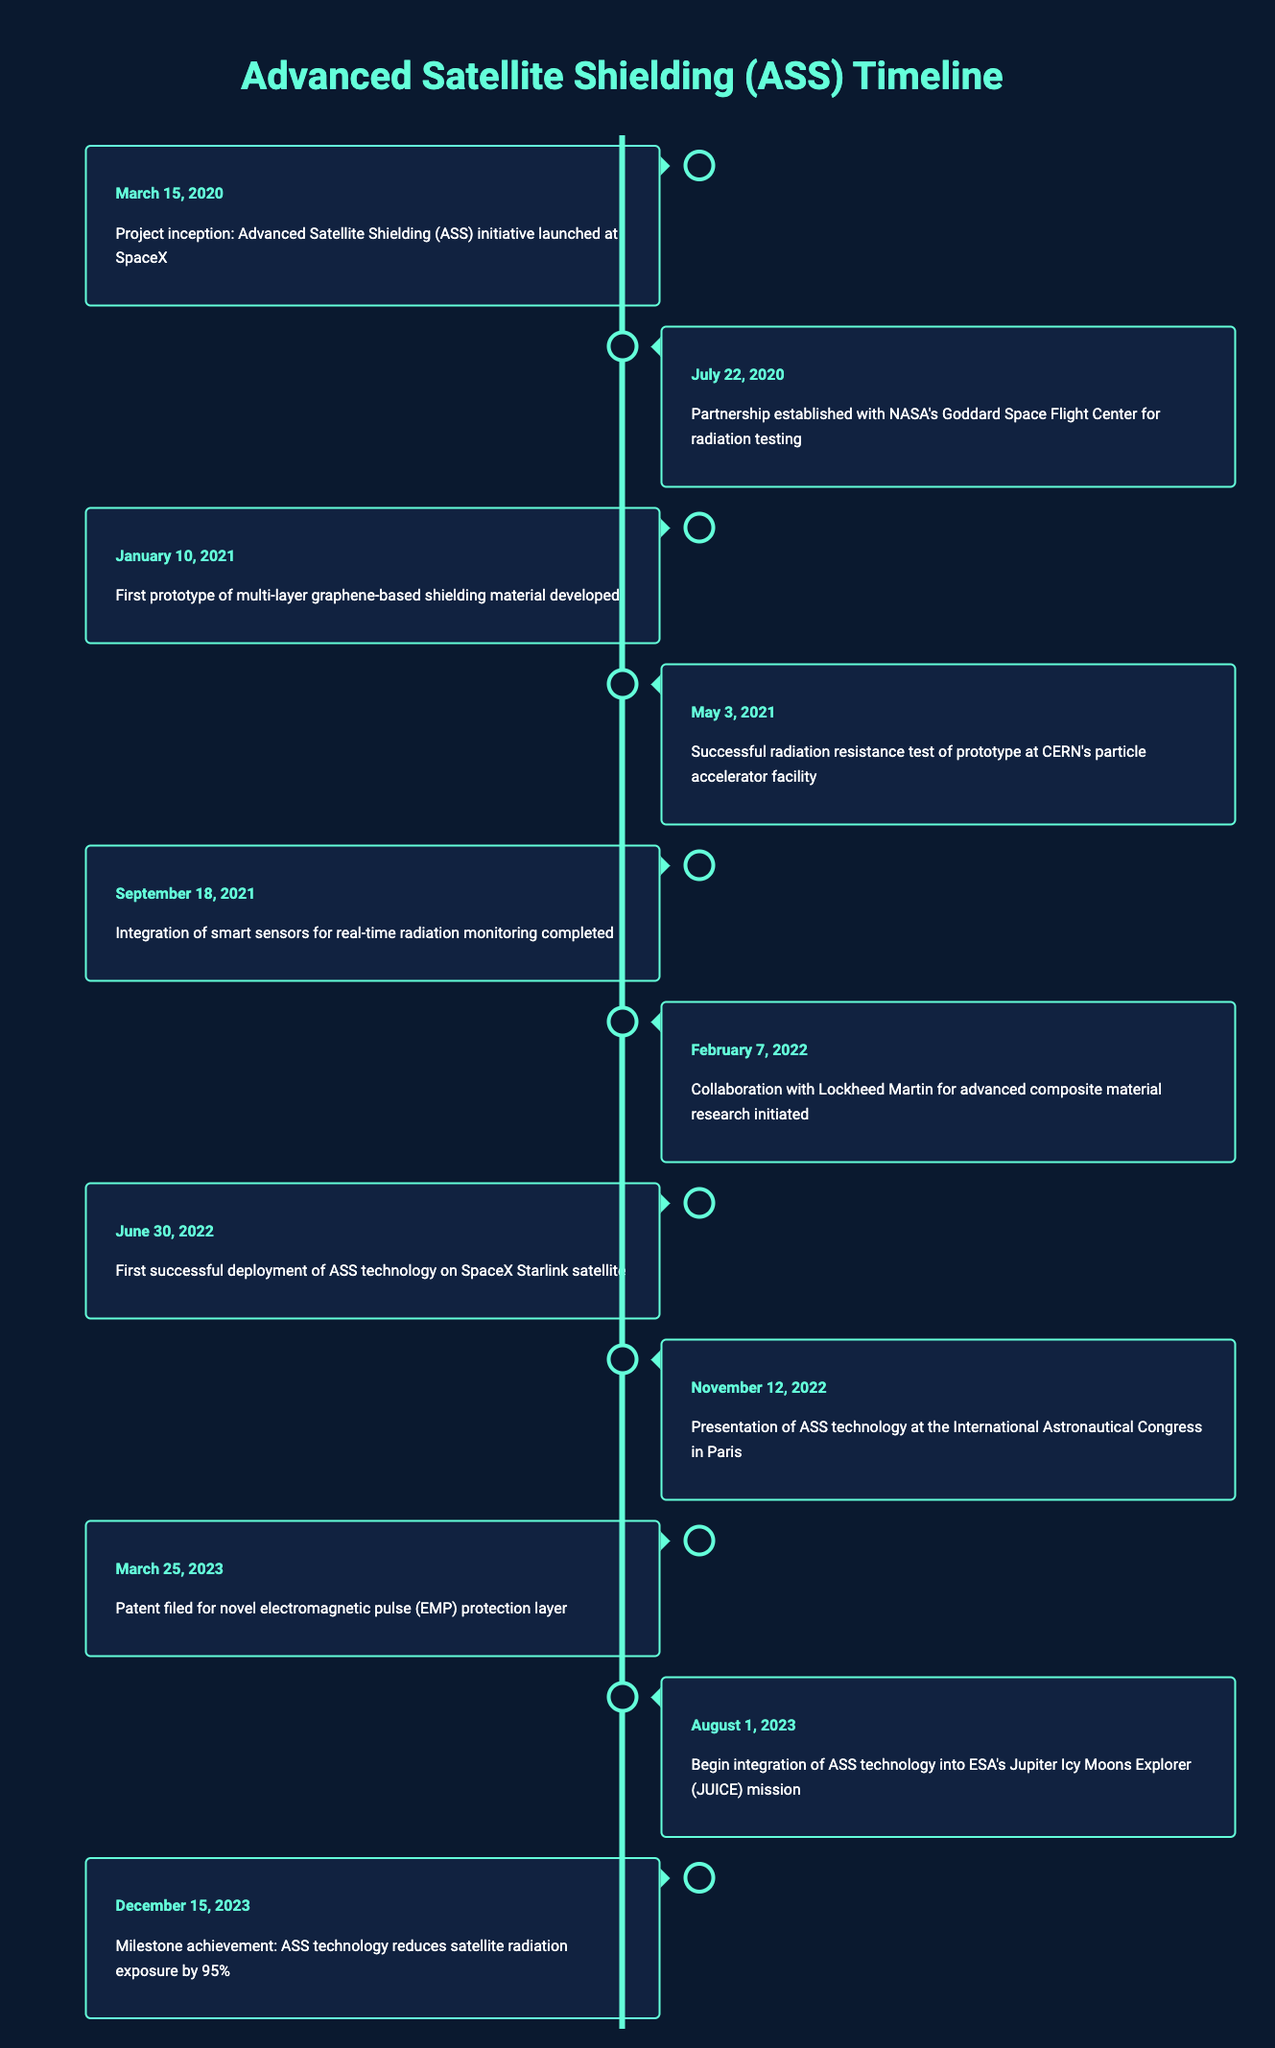What date did the Advanced Satellite Shielding project begin? The table shows the event for the project inception is on March 15, 2020. Therefore, this is the date the project began.
Answer: March 15, 2020 When was the first prototype of the shielding material developed? The third entry in the timeline lists January 10, 2021, as the date when the first prototype of multi-layer graphene-based shielding material was developed.
Answer: January 10, 2021 Was there a successful radiation resistance test conducted for the prototype, and if so, when? Yes, the timeline indicates that a successful radiation resistance test was conducted on May 3, 2021, at CERN's facility.
Answer: Yes, May 3, 2021 How many months were there between the project inception and the first successful deployment of the ASS technology? The project began on March 15, 2020, and the first successful deployment occurred on June 30, 2022. The difference in months is from March 2020 to June 2022, which is 27 months.
Answer: 27 months What milestone was achieved on December 15, 2023? The last entry in the timeline states that on December 15, 2023, a milestone was achieved where ASS technology reduces satellite radiation exposure by 95%.
Answer: ASS technology reduces satellite radiation exposure by 95% In what year was the collaboration with Lockheed Martin initiated? The timeline shows that the collaboration with Lockheed Martin began on February 7, 2022, which indicates this event took place in 2022.
Answer: 2022 Did the ASS technology get presented at an international congress, and what was the date? Yes, the table states that the ASS technology was presented at the International Astronautical Congress on November 12, 2022.
Answer: Yes, November 12, 2022 How many major technology developments happened in the year 2023? The entries for 2023 are on March 25 and August 1, indicating there were two major developments in that year.
Answer: 2 Which event occurred first: the integration of smart sensors or the successful deployment of ASS technology? A review of the timeline shows that the integration of smart sensors happened on September 18, 2021, while the successful deployment occurred on June 30, 2022. Therefore, the integration of smart sensors occurred first.
Answer: Integration of smart sensors 